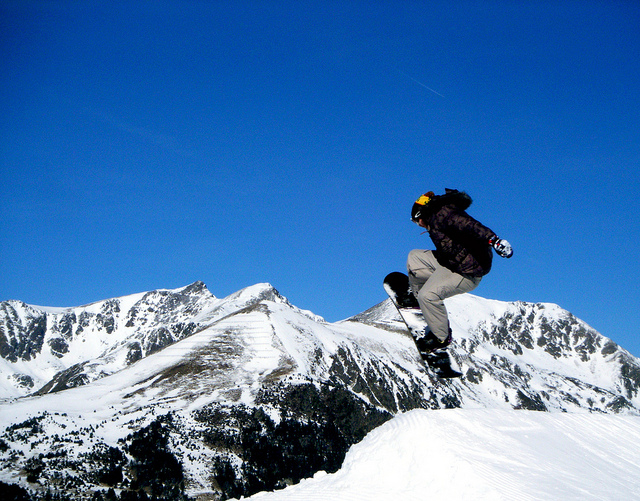<image>What size will the storm be? It is unknown what size the storm will be. The image does not provide sufficient information. What size will the storm be? I am not sure what size the storm will be. It can be small, big or none at all. 